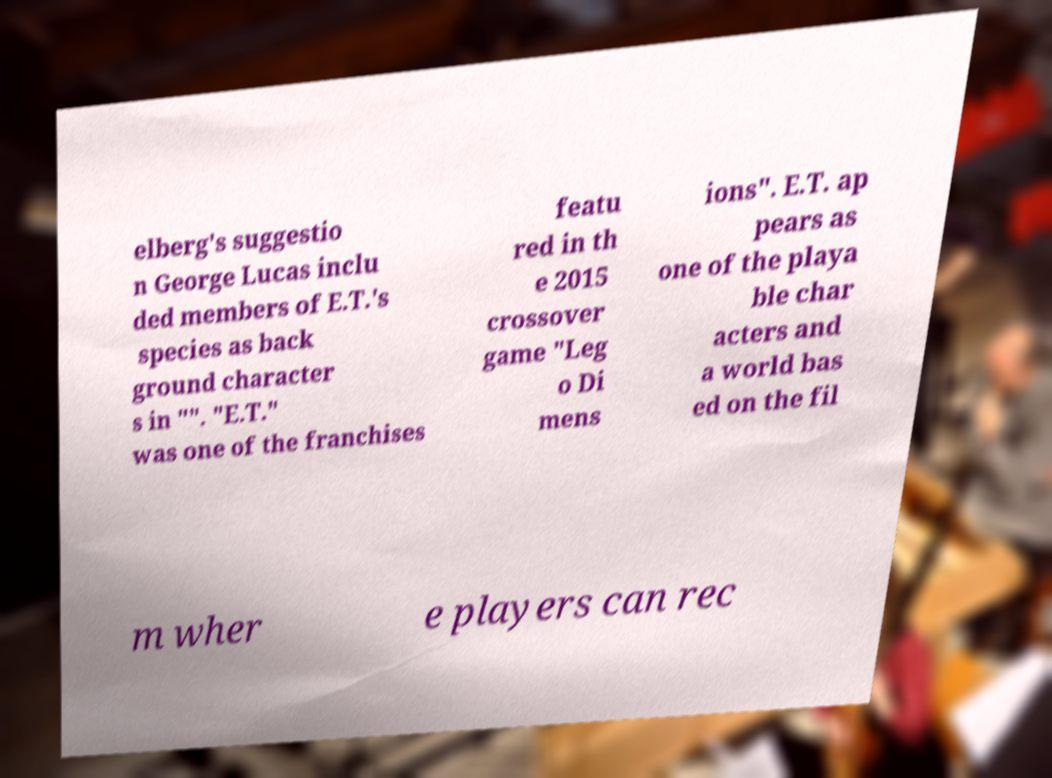For documentation purposes, I need the text within this image transcribed. Could you provide that? elberg's suggestio n George Lucas inclu ded members of E.T.'s species as back ground character s in "". "E.T." was one of the franchises featu red in th e 2015 crossover game "Leg o Di mens ions". E.T. ap pears as one of the playa ble char acters and a world bas ed on the fil m wher e players can rec 